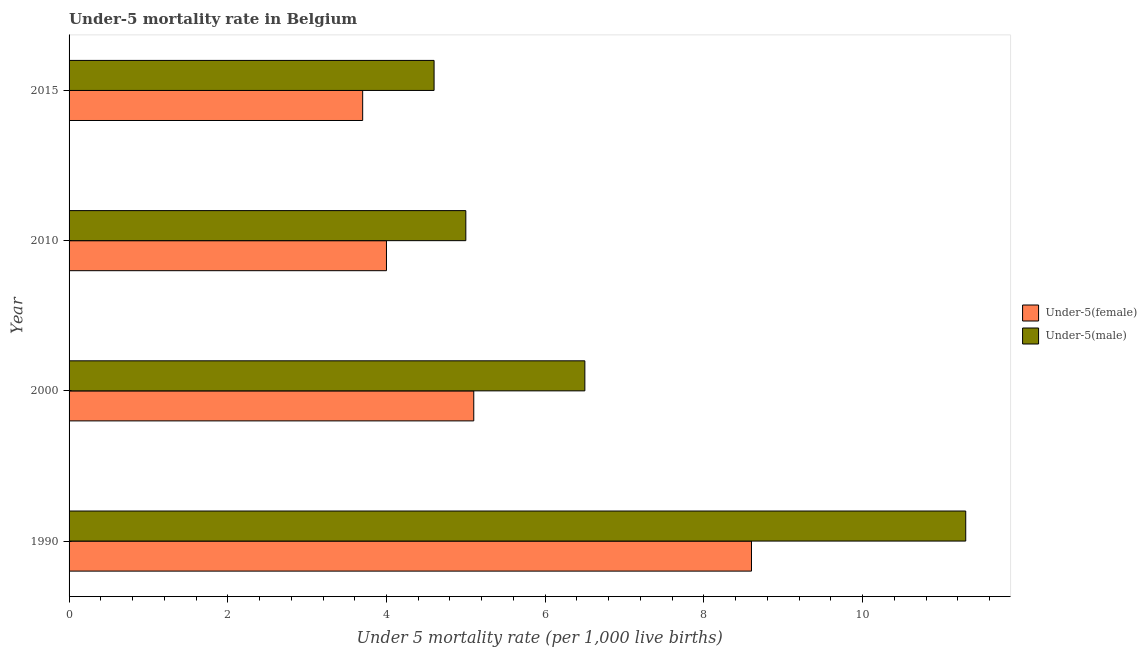How many groups of bars are there?
Your answer should be compact. 4. Are the number of bars per tick equal to the number of legend labels?
Offer a terse response. Yes. How many bars are there on the 4th tick from the bottom?
Your answer should be compact. 2. What is the label of the 1st group of bars from the top?
Give a very brief answer. 2015. In which year was the under-5 female mortality rate maximum?
Your answer should be compact. 1990. In which year was the under-5 female mortality rate minimum?
Offer a terse response. 2015. What is the total under-5 male mortality rate in the graph?
Offer a terse response. 27.4. What is the difference between the under-5 female mortality rate in 1990 and that in 2010?
Your response must be concise. 4.6. What is the difference between the under-5 female mortality rate in 2015 and the under-5 male mortality rate in 2000?
Your response must be concise. -2.8. What is the average under-5 male mortality rate per year?
Ensure brevity in your answer.  6.85. In the year 2000, what is the difference between the under-5 female mortality rate and under-5 male mortality rate?
Your answer should be compact. -1.4. In how many years, is the under-5 male mortality rate greater than 5.6 ?
Offer a terse response. 2. What is the ratio of the under-5 female mortality rate in 1990 to that in 2015?
Offer a very short reply. 2.32. Is the difference between the under-5 female mortality rate in 1990 and 2010 greater than the difference between the under-5 male mortality rate in 1990 and 2010?
Ensure brevity in your answer.  No. What is the difference between the highest and the lowest under-5 male mortality rate?
Provide a short and direct response. 6.7. In how many years, is the under-5 male mortality rate greater than the average under-5 male mortality rate taken over all years?
Provide a succinct answer. 1. Is the sum of the under-5 male mortality rate in 2000 and 2015 greater than the maximum under-5 female mortality rate across all years?
Your answer should be compact. Yes. What does the 2nd bar from the top in 2000 represents?
Offer a very short reply. Under-5(female). What does the 2nd bar from the bottom in 2000 represents?
Offer a very short reply. Under-5(male). How many bars are there?
Give a very brief answer. 8. Are all the bars in the graph horizontal?
Provide a succinct answer. Yes. What is the difference between two consecutive major ticks on the X-axis?
Your answer should be very brief. 2. Are the values on the major ticks of X-axis written in scientific E-notation?
Provide a succinct answer. No. Does the graph contain grids?
Provide a succinct answer. No. How many legend labels are there?
Keep it short and to the point. 2. What is the title of the graph?
Make the answer very short. Under-5 mortality rate in Belgium. Does "Working capital" appear as one of the legend labels in the graph?
Provide a succinct answer. No. What is the label or title of the X-axis?
Your answer should be very brief. Under 5 mortality rate (per 1,0 live births). What is the label or title of the Y-axis?
Offer a very short reply. Year. What is the Under 5 mortality rate (per 1,000 live births) of Under-5(male) in 1990?
Provide a short and direct response. 11.3. What is the Under 5 mortality rate (per 1,000 live births) in Under-5(female) in 2000?
Your answer should be very brief. 5.1. What is the Under 5 mortality rate (per 1,000 live births) of Under-5(male) in 2000?
Ensure brevity in your answer.  6.5. What is the Under 5 mortality rate (per 1,000 live births) of Under-5(female) in 2010?
Provide a short and direct response. 4. What is the Under 5 mortality rate (per 1,000 live births) in Under-5(male) in 2015?
Make the answer very short. 4.6. Across all years, what is the maximum Under 5 mortality rate (per 1,000 live births) of Under-5(male)?
Your response must be concise. 11.3. Across all years, what is the minimum Under 5 mortality rate (per 1,000 live births) of Under-5(male)?
Ensure brevity in your answer.  4.6. What is the total Under 5 mortality rate (per 1,000 live births) in Under-5(female) in the graph?
Ensure brevity in your answer.  21.4. What is the total Under 5 mortality rate (per 1,000 live births) of Under-5(male) in the graph?
Offer a very short reply. 27.4. What is the difference between the Under 5 mortality rate (per 1,000 live births) in Under-5(female) in 1990 and that in 2000?
Offer a very short reply. 3.5. What is the difference between the Under 5 mortality rate (per 1,000 live births) of Under-5(male) in 1990 and that in 2000?
Provide a short and direct response. 4.8. What is the difference between the Under 5 mortality rate (per 1,000 live births) of Under-5(female) in 1990 and that in 2010?
Ensure brevity in your answer.  4.6. What is the difference between the Under 5 mortality rate (per 1,000 live births) in Under-5(male) in 1990 and that in 2010?
Give a very brief answer. 6.3. What is the difference between the Under 5 mortality rate (per 1,000 live births) of Under-5(male) in 1990 and that in 2015?
Offer a very short reply. 6.7. What is the difference between the Under 5 mortality rate (per 1,000 live births) in Under-5(female) in 2000 and that in 2015?
Offer a terse response. 1.4. What is the difference between the Under 5 mortality rate (per 1,000 live births) in Under-5(male) in 2000 and that in 2015?
Provide a succinct answer. 1.9. What is the difference between the Under 5 mortality rate (per 1,000 live births) of Under-5(female) in 2000 and the Under 5 mortality rate (per 1,000 live births) of Under-5(male) in 2015?
Your answer should be compact. 0.5. What is the difference between the Under 5 mortality rate (per 1,000 live births) of Under-5(female) in 2010 and the Under 5 mortality rate (per 1,000 live births) of Under-5(male) in 2015?
Your response must be concise. -0.6. What is the average Under 5 mortality rate (per 1,000 live births) in Under-5(female) per year?
Keep it short and to the point. 5.35. What is the average Under 5 mortality rate (per 1,000 live births) of Under-5(male) per year?
Your response must be concise. 6.85. In the year 2000, what is the difference between the Under 5 mortality rate (per 1,000 live births) in Under-5(female) and Under 5 mortality rate (per 1,000 live births) in Under-5(male)?
Provide a succinct answer. -1.4. What is the ratio of the Under 5 mortality rate (per 1,000 live births) of Under-5(female) in 1990 to that in 2000?
Your answer should be very brief. 1.69. What is the ratio of the Under 5 mortality rate (per 1,000 live births) of Under-5(male) in 1990 to that in 2000?
Offer a very short reply. 1.74. What is the ratio of the Under 5 mortality rate (per 1,000 live births) in Under-5(female) in 1990 to that in 2010?
Ensure brevity in your answer.  2.15. What is the ratio of the Under 5 mortality rate (per 1,000 live births) of Under-5(male) in 1990 to that in 2010?
Make the answer very short. 2.26. What is the ratio of the Under 5 mortality rate (per 1,000 live births) in Under-5(female) in 1990 to that in 2015?
Keep it short and to the point. 2.32. What is the ratio of the Under 5 mortality rate (per 1,000 live births) in Under-5(male) in 1990 to that in 2015?
Make the answer very short. 2.46. What is the ratio of the Under 5 mortality rate (per 1,000 live births) of Under-5(female) in 2000 to that in 2010?
Make the answer very short. 1.27. What is the ratio of the Under 5 mortality rate (per 1,000 live births) of Under-5(male) in 2000 to that in 2010?
Your answer should be very brief. 1.3. What is the ratio of the Under 5 mortality rate (per 1,000 live births) of Under-5(female) in 2000 to that in 2015?
Ensure brevity in your answer.  1.38. What is the ratio of the Under 5 mortality rate (per 1,000 live births) in Under-5(male) in 2000 to that in 2015?
Provide a short and direct response. 1.41. What is the ratio of the Under 5 mortality rate (per 1,000 live births) of Under-5(female) in 2010 to that in 2015?
Keep it short and to the point. 1.08. What is the ratio of the Under 5 mortality rate (per 1,000 live births) in Under-5(male) in 2010 to that in 2015?
Your answer should be compact. 1.09. What is the difference between the highest and the second highest Under 5 mortality rate (per 1,000 live births) of Under-5(female)?
Give a very brief answer. 3.5. What is the difference between the highest and the second highest Under 5 mortality rate (per 1,000 live births) of Under-5(male)?
Ensure brevity in your answer.  4.8. What is the difference between the highest and the lowest Under 5 mortality rate (per 1,000 live births) in Under-5(male)?
Your response must be concise. 6.7. 